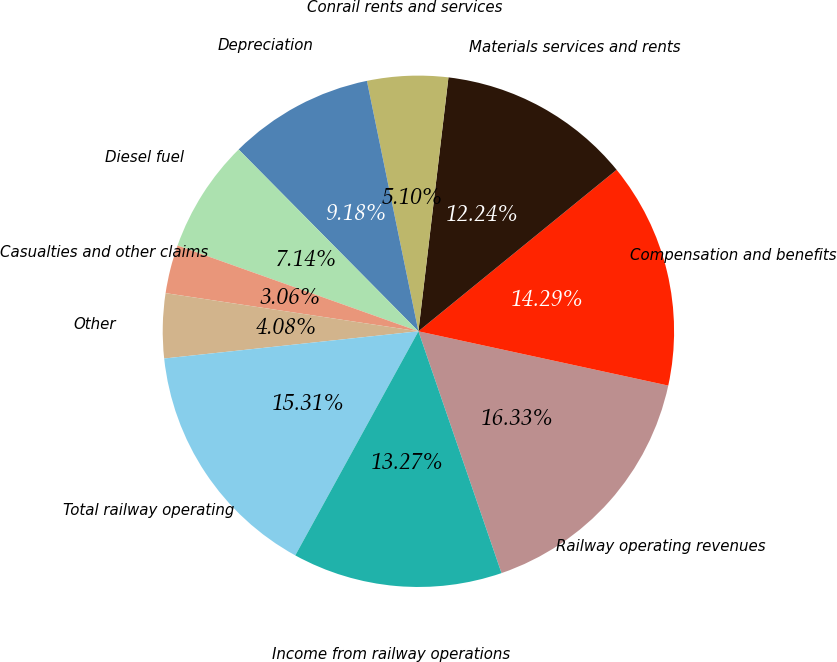Convert chart. <chart><loc_0><loc_0><loc_500><loc_500><pie_chart><fcel>Railway operating revenues<fcel>Compensation and benefits<fcel>Materials services and rents<fcel>Conrail rents and services<fcel>Depreciation<fcel>Diesel fuel<fcel>Casualties and other claims<fcel>Other<fcel>Total railway operating<fcel>Income from railway operations<nl><fcel>16.32%<fcel>14.28%<fcel>12.24%<fcel>5.1%<fcel>9.18%<fcel>7.14%<fcel>3.06%<fcel>4.08%<fcel>15.3%<fcel>13.26%<nl></chart> 